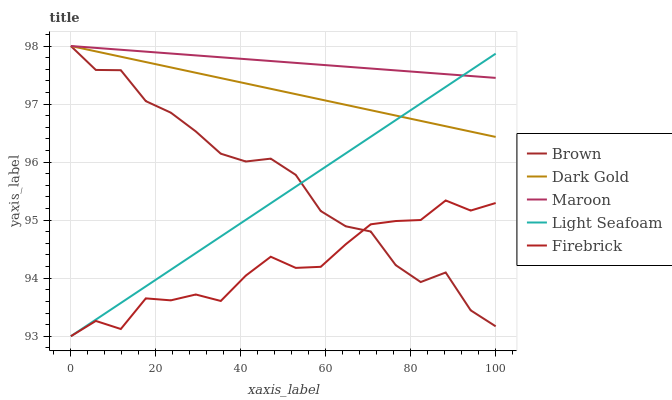Does Firebrick have the minimum area under the curve?
Answer yes or no. Yes. Does Maroon have the maximum area under the curve?
Answer yes or no. Yes. Does Light Seafoam have the minimum area under the curve?
Answer yes or no. No. Does Light Seafoam have the maximum area under the curve?
Answer yes or no. No. Is Light Seafoam the smoothest?
Answer yes or no. Yes. Is Brown the roughest?
Answer yes or no. Yes. Is Firebrick the smoothest?
Answer yes or no. No. Is Firebrick the roughest?
Answer yes or no. No. Does Firebrick have the lowest value?
Answer yes or no. Yes. Does Maroon have the lowest value?
Answer yes or no. No. Does Dark Gold have the highest value?
Answer yes or no. Yes. Does Light Seafoam have the highest value?
Answer yes or no. No. Is Firebrick less than Maroon?
Answer yes or no. Yes. Is Maroon greater than Firebrick?
Answer yes or no. Yes. Does Firebrick intersect Brown?
Answer yes or no. Yes. Is Firebrick less than Brown?
Answer yes or no. No. Is Firebrick greater than Brown?
Answer yes or no. No. Does Firebrick intersect Maroon?
Answer yes or no. No. 